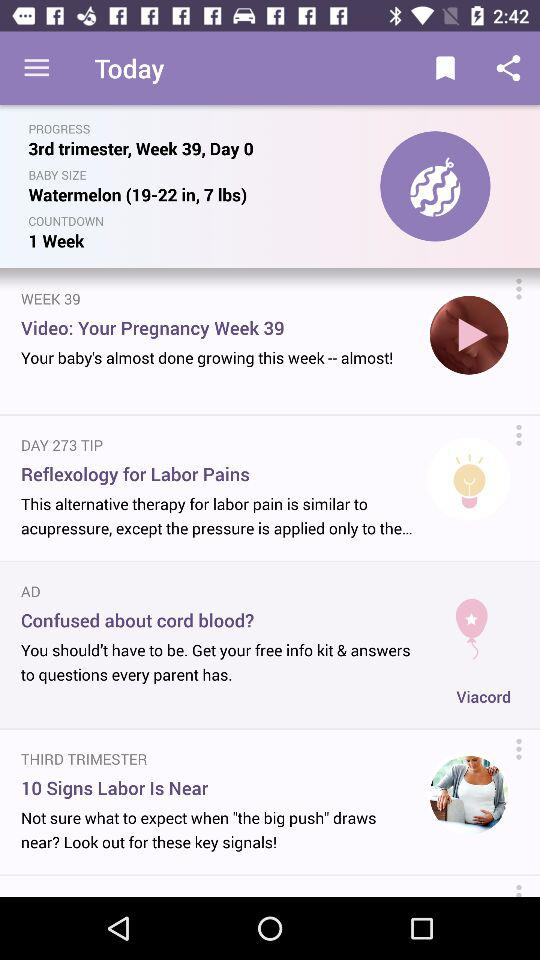How many days are left until the due date?
Answer the question using a single word or phrase. 1 week 